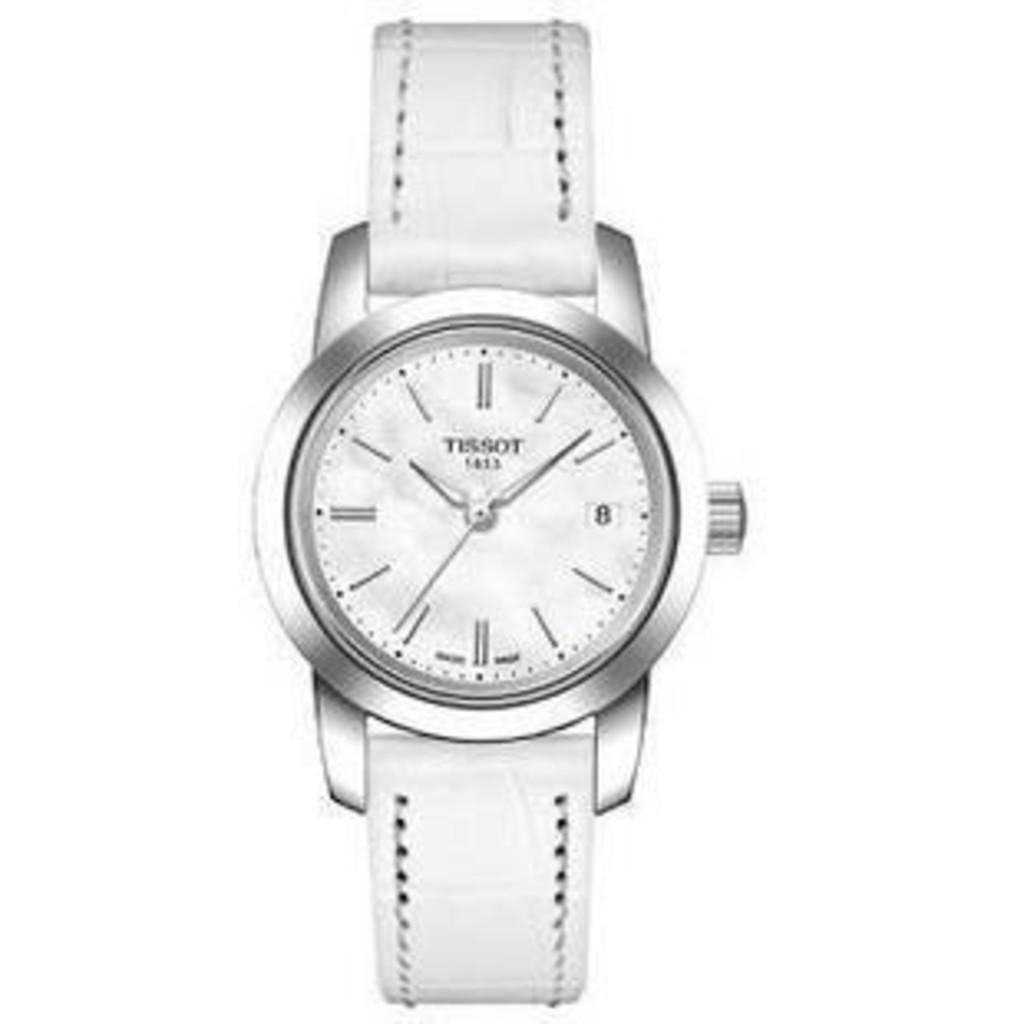Provide a one-sentence caption for the provided image. A white Tisson wrist watch is displayed on a white back ground. 